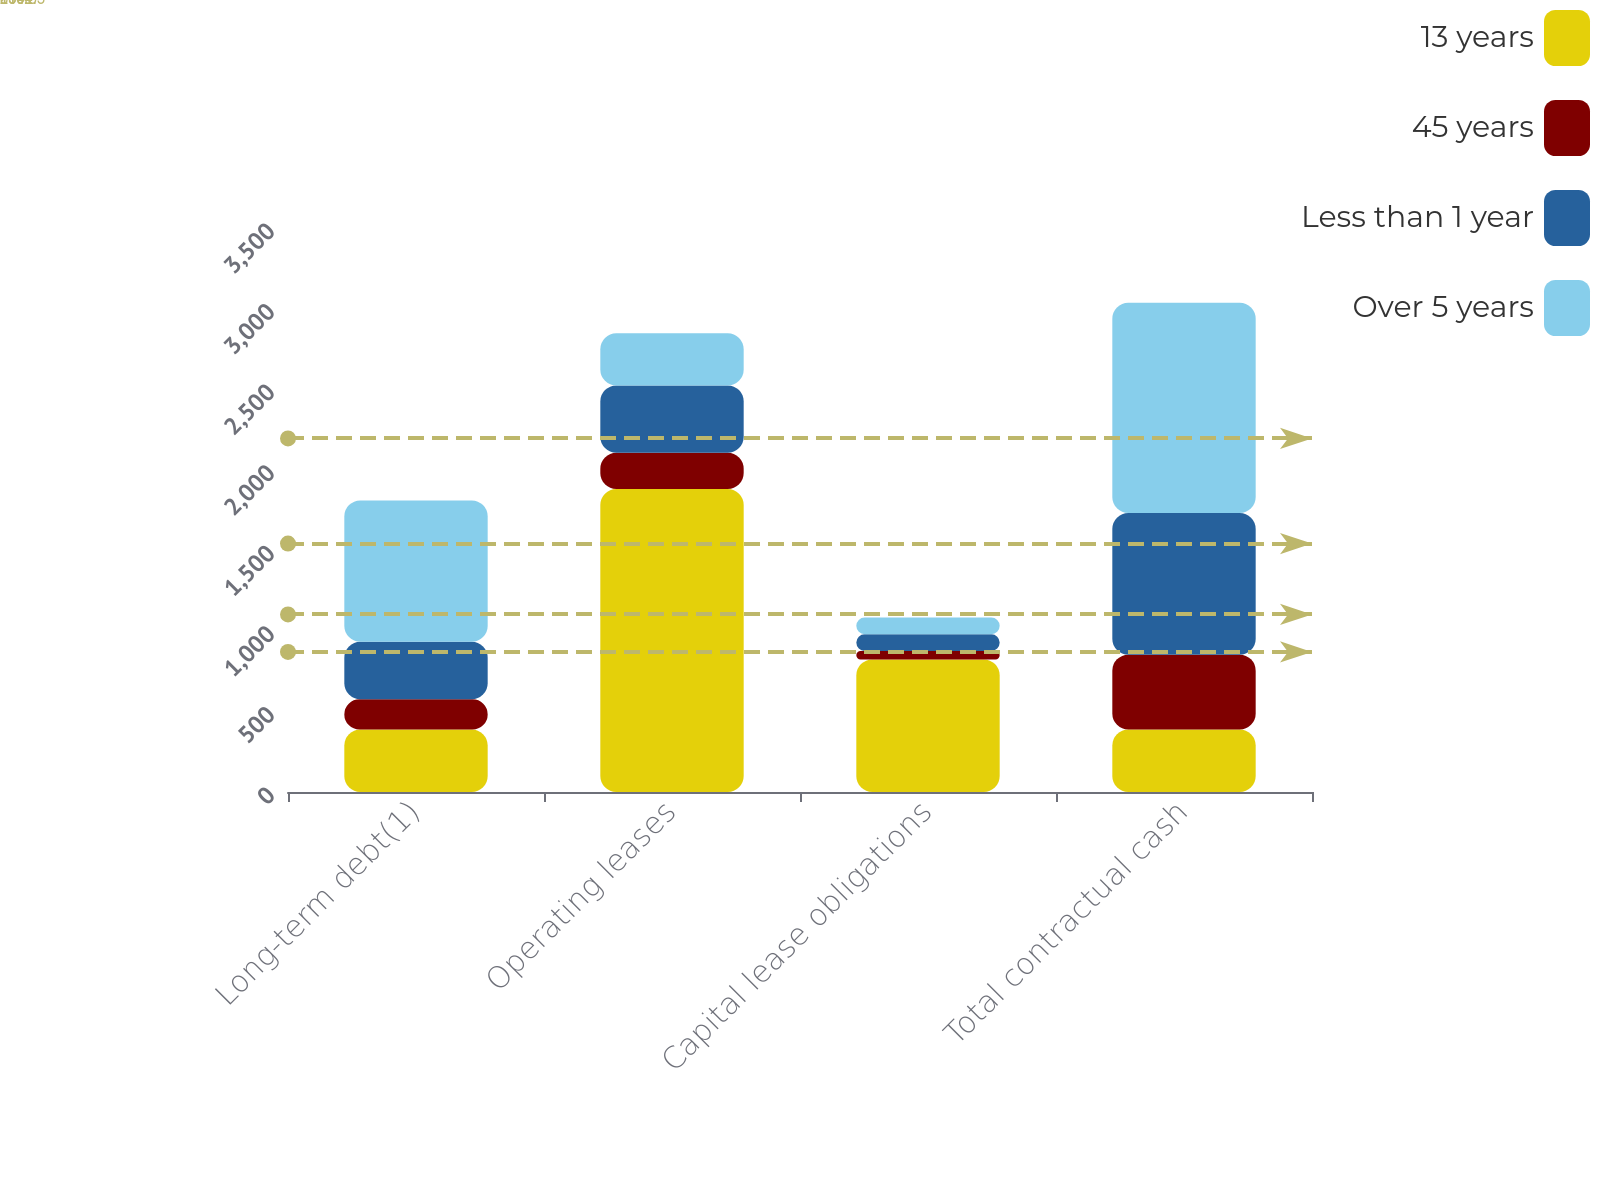Convert chart. <chart><loc_0><loc_0><loc_500><loc_500><stacked_bar_chart><ecel><fcel>Long-term debt(1)<fcel>Operating leases<fcel>Capital lease obligations<fcel>Total contractual cash<nl><fcel>13 years<fcel>387.5<fcel>1880<fcel>823<fcel>387.5<nl><fcel>45 years<fcel>188<fcel>225<fcel>52<fcel>465<nl><fcel>Less than 1 year<fcel>357<fcel>418<fcel>104<fcel>879<nl><fcel>Over 5 years<fcel>877<fcel>324<fcel>104<fcel>1305<nl></chart> 